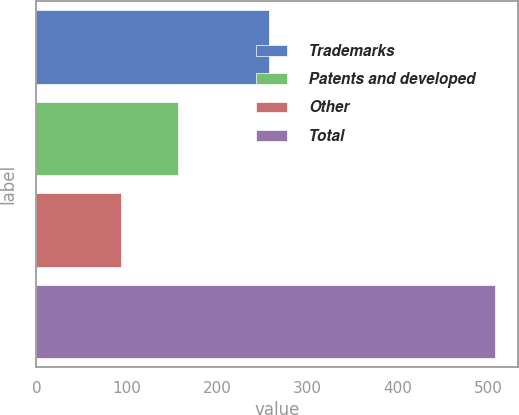Convert chart to OTSL. <chart><loc_0><loc_0><loc_500><loc_500><bar_chart><fcel>Trademarks<fcel>Patents and developed<fcel>Other<fcel>Total<nl><fcel>257<fcel>157<fcel>93<fcel>507<nl></chart> 